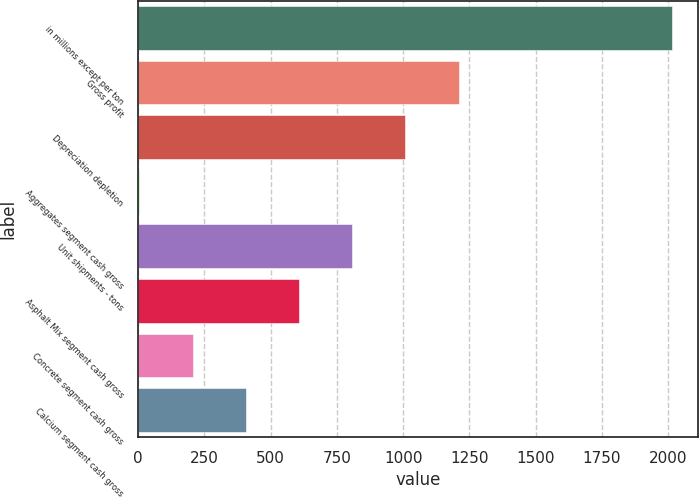<chart> <loc_0><loc_0><loc_500><loc_500><bar_chart><fcel>in millions except per ton<fcel>Gross profit<fcel>Depreciation depletion<fcel>Aggregates segment cash gross<fcel>Unit shipments - tons<fcel>Asphalt Mix segment cash gross<fcel>Concrete segment cash gross<fcel>Calcium segment cash gross<nl><fcel>2013<fcel>1209.53<fcel>1008.67<fcel>4.37<fcel>807.81<fcel>606.95<fcel>205.23<fcel>406.09<nl></chart> 